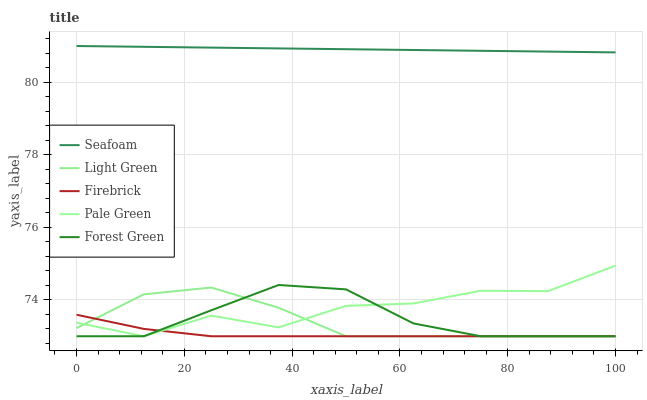Does Pale Green have the minimum area under the curve?
Answer yes or no. No. Does Pale Green have the maximum area under the curve?
Answer yes or no. No. Is Firebrick the smoothest?
Answer yes or no. No. Is Firebrick the roughest?
Answer yes or no. No. Does Seafoam have the lowest value?
Answer yes or no. No. Does Pale Green have the highest value?
Answer yes or no. No. Is Forest Green less than Seafoam?
Answer yes or no. Yes. Is Seafoam greater than Forest Green?
Answer yes or no. Yes. Does Forest Green intersect Seafoam?
Answer yes or no. No. 